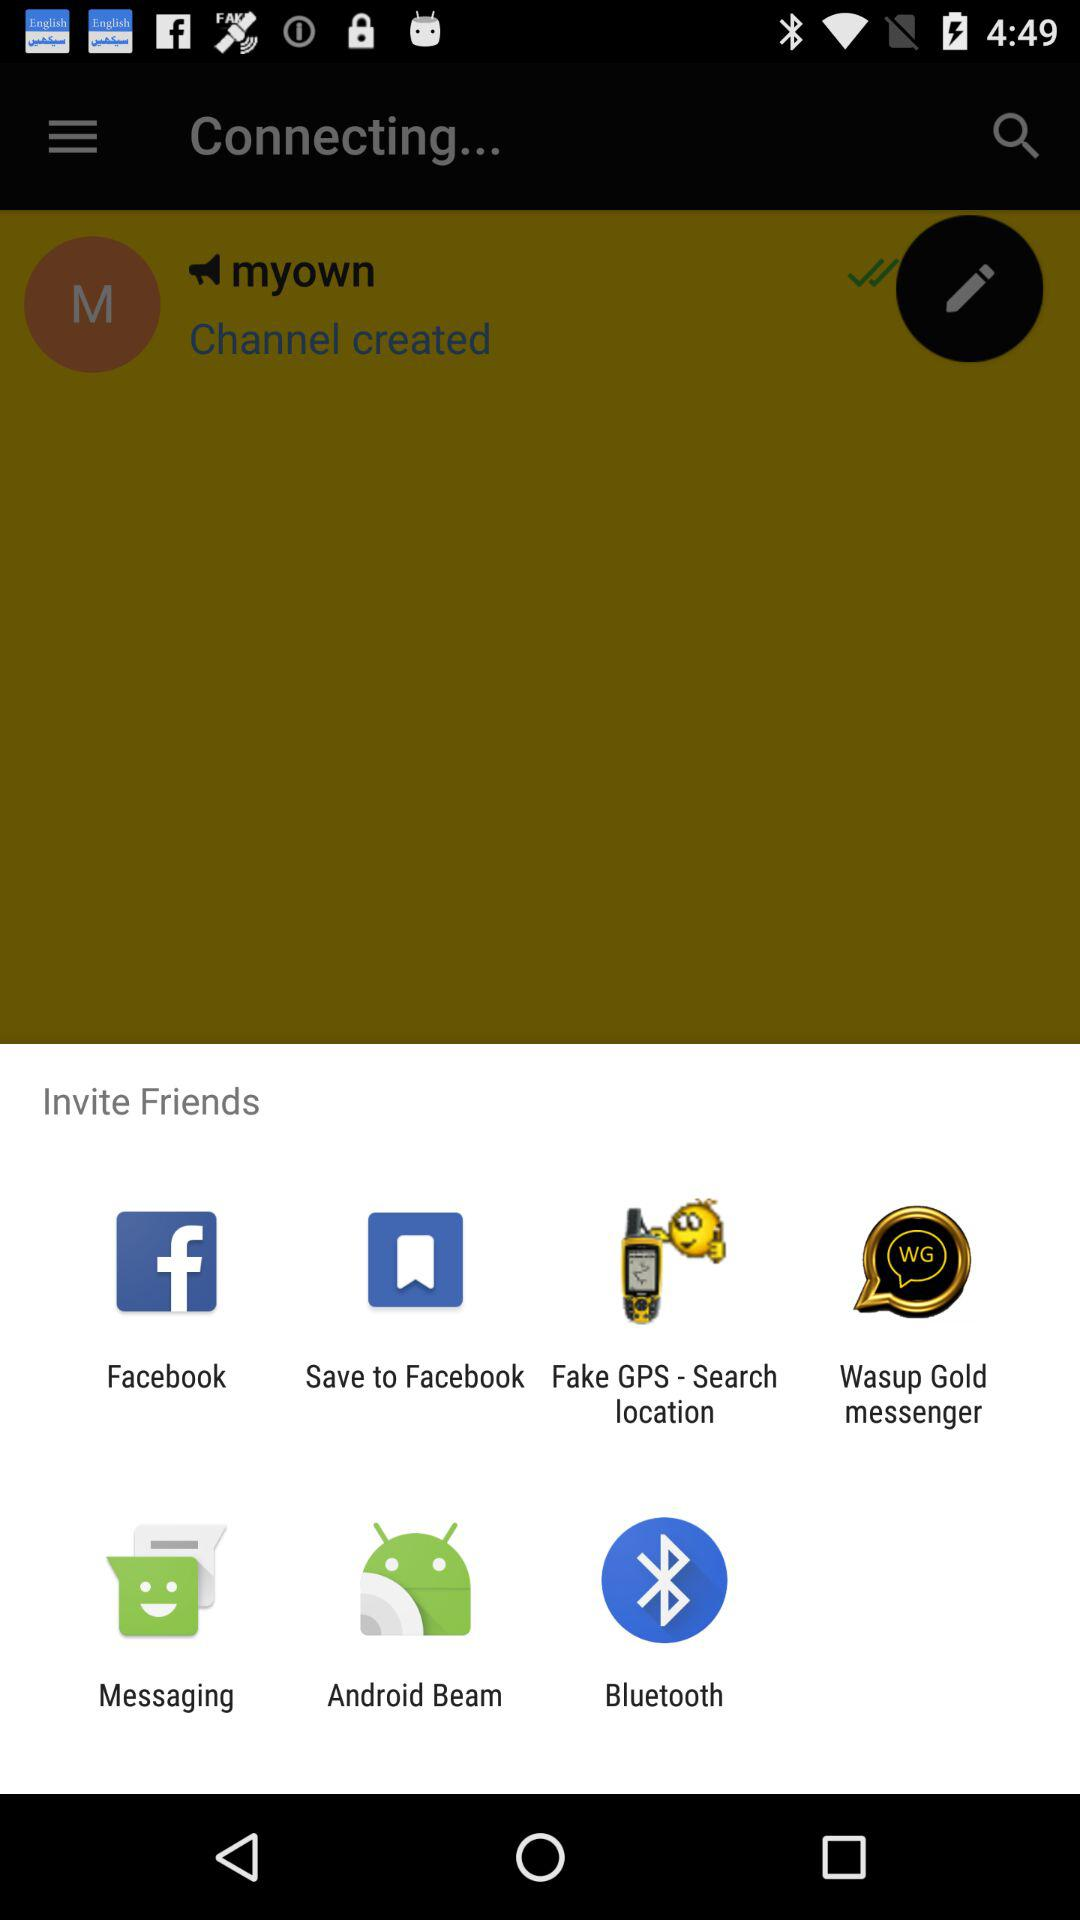Which applications can I use to invite my friends? The applications are "Facebook", "Save to Facebook", "Fake GPS - Search location", "Wasup Gold messenger", "Messaging", "Android Beam" and "Bluetooth". 